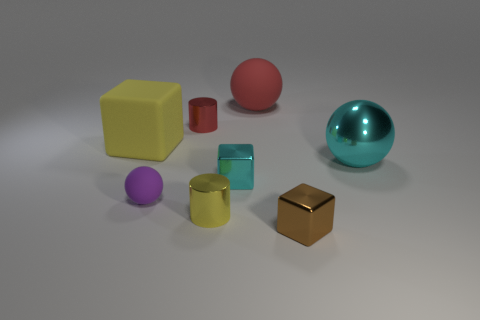Is the shape of the small rubber object the same as the cyan object that is left of the metal sphere?
Keep it short and to the point. No. What material is the block that is in front of the purple matte sphere in front of the small cyan cube?
Your response must be concise. Metal. Are there the same number of small red things on the left side of the small brown object and gray matte cylinders?
Your answer should be compact. No. Is there anything else that is the same material as the small purple object?
Provide a short and direct response. Yes. There is a big thing right of the brown metal object; is its color the same as the big sphere that is on the left side of the big cyan metal thing?
Provide a short and direct response. No. What number of objects are right of the yellow metal cylinder and behind the large yellow rubber thing?
Offer a very short reply. 1. What number of other objects are there of the same shape as the tiny cyan metal object?
Provide a succinct answer. 2. Is the number of tiny cyan blocks behind the large cyan metal object greater than the number of tiny cyan metallic spheres?
Your response must be concise. No. What is the color of the small cylinder that is in front of the big metal object?
Offer a very short reply. Yellow. There is a metal cylinder that is the same color as the big matte ball; what is its size?
Make the answer very short. Small. 